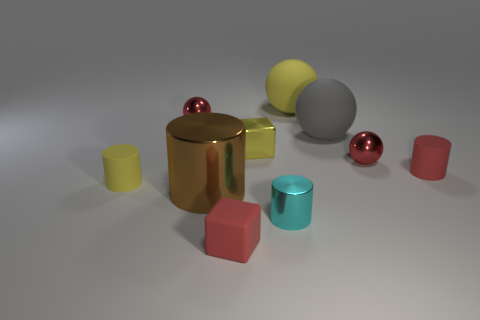Is the number of gray spheres in front of the red matte cylinder the same as the number of tiny red cylinders?
Keep it short and to the point. No. What shape is the brown object that is the same size as the yellow matte ball?
Your answer should be compact. Cylinder. What material is the tiny cyan cylinder?
Offer a very short reply. Metal. The ball that is both to the left of the gray sphere and in front of the big yellow thing is what color?
Provide a succinct answer. Red. Are there the same number of cyan metallic cylinders that are behind the large gray matte sphere and tiny red rubber cylinders that are on the left side of the brown shiny object?
Your answer should be very brief. Yes. What is the color of the other big object that is made of the same material as the gray object?
Keep it short and to the point. Yellow. There is a matte block; is its color the same as the shiny thing behind the yellow cube?
Your answer should be compact. Yes. There is a tiny matte cylinder that is on the left side of the tiny metal ball on the right side of the tiny rubber block; is there a metal cylinder that is behind it?
Keep it short and to the point. No. There is a big yellow thing that is made of the same material as the red block; what shape is it?
Your answer should be compact. Sphere. What shape is the large gray object?
Ensure brevity in your answer.  Sphere. 